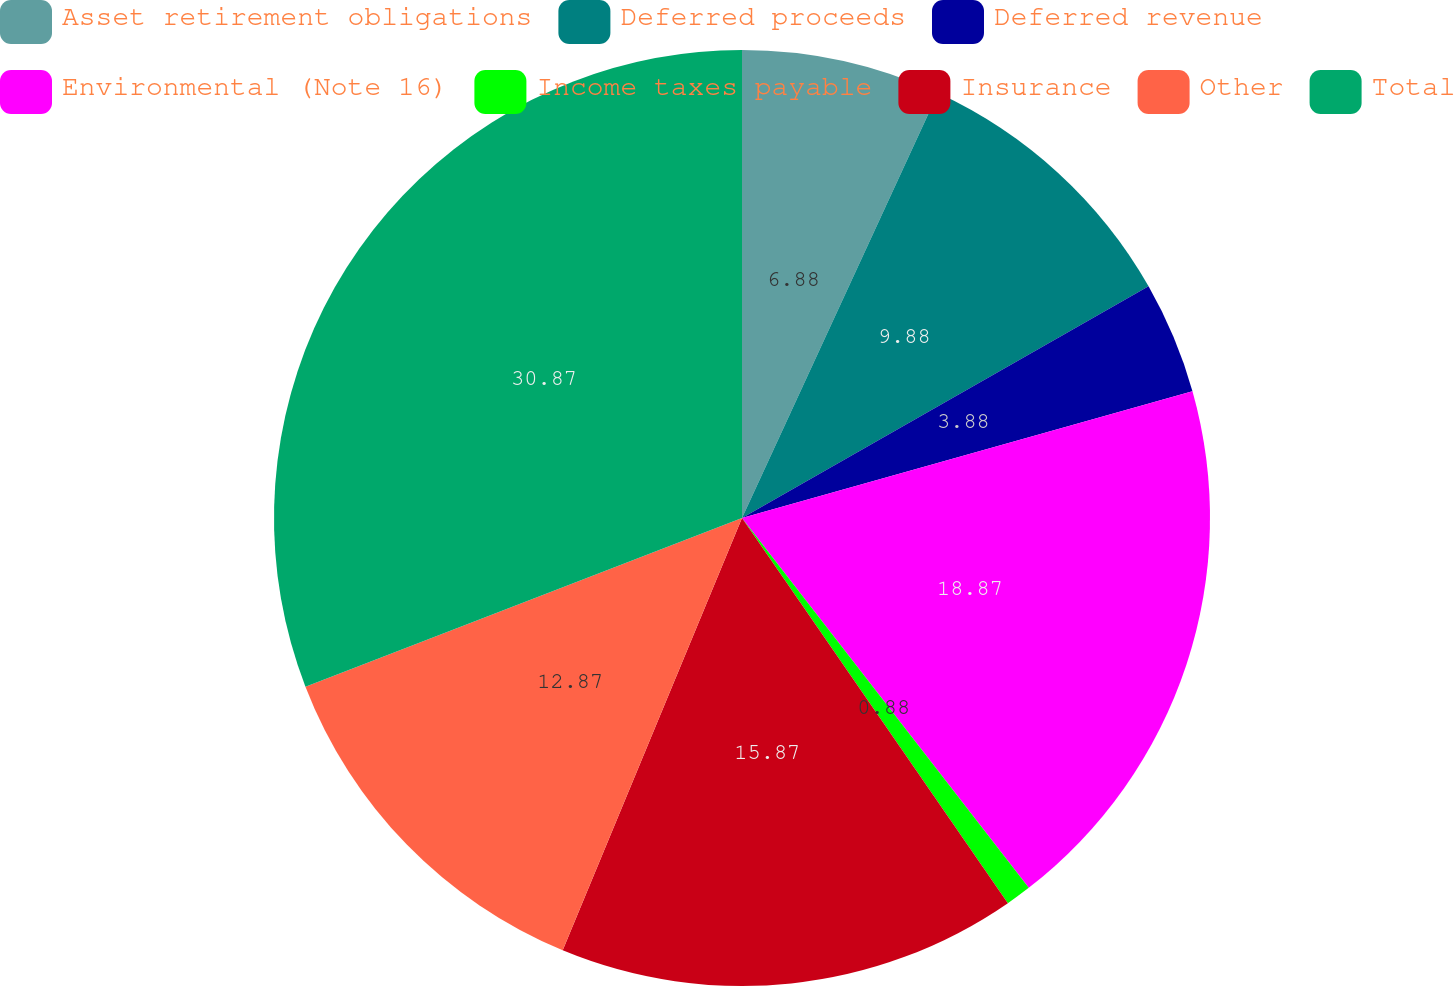Convert chart. <chart><loc_0><loc_0><loc_500><loc_500><pie_chart><fcel>Asset retirement obligations<fcel>Deferred proceeds<fcel>Deferred revenue<fcel>Environmental (Note 16)<fcel>Income taxes payable<fcel>Insurance<fcel>Other<fcel>Total<nl><fcel>6.88%<fcel>9.88%<fcel>3.88%<fcel>18.88%<fcel>0.88%<fcel>15.88%<fcel>12.88%<fcel>30.88%<nl></chart> 